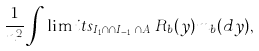Convert formula to latex. <formula><loc_0><loc_0><loc_500><loc_500>\frac { 1 } { n ^ { 2 } } \int \lim i t s _ { I _ { 1 } \cap \dots \cap I _ { i - 1 } \cap A _ { i } } R _ { b } ( y ) m _ { b } ( d y ) ,</formula> 